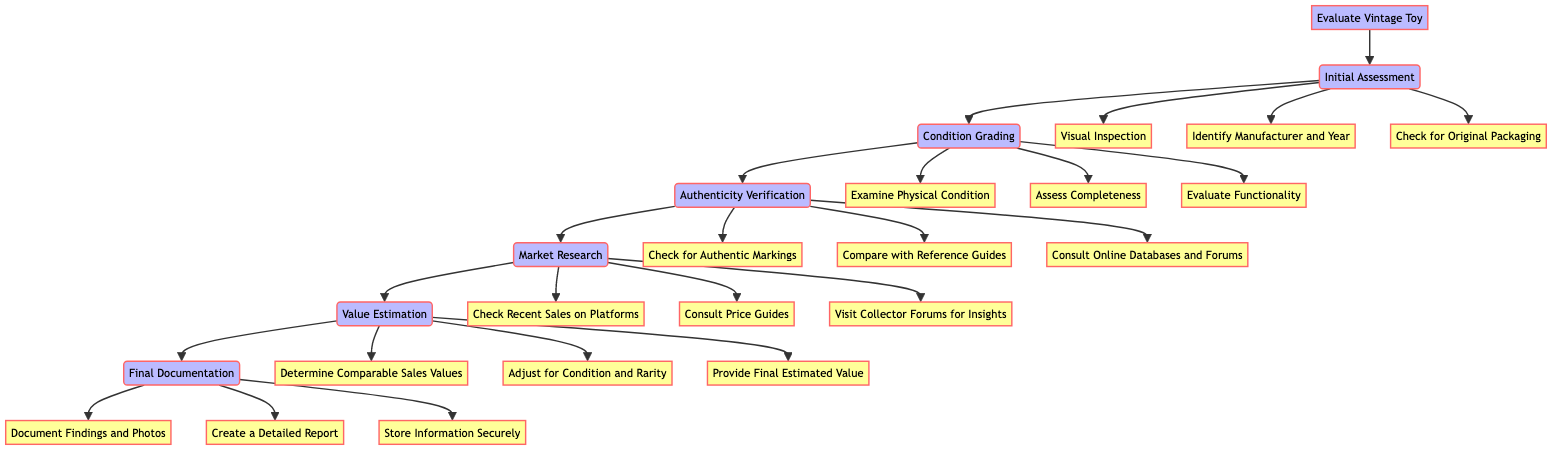What is the first step in the process? The diagram clearly indicates that the first step in the process is the "Initial Assessment." This is shown as the first node after the starting point.
Answer: Initial Assessment How many actions are listed under "Condition Grading"? In the diagram, the "Condition Grading" step has three actions connected to it: "Examine Physical Condition," "Assess Completeness," and "Evaluate Functionality." Therefore, the count of actions is three.
Answer: Three What are the actions included in the "Final Documentation" step? The "Final Documentation" step has three specific actions outlined: "Document Findings and Photos," "Create a Detailed Report," and "Store Information Securely." These actions represent the tasks to be completed during this step.
Answer: Document Findings and Photos, Create a Detailed Report, Store Information Securely Which step follows "Authenticity Verification"? Looking at the flowchart, the step that follows "Authenticity Verification" is "Market Research." This relationship is explicitly defined by the directional arrow connecting the two steps.
Answer: Market Research What is the last step in the evaluation process? According to the diagram, the last step in the evaluation process is "Final Documentation." This is the last node connected to the flowchart sequence, indicating it concludes the process.
Answer: Final Documentation Which step involves checking for recent sales on platforms like eBay? The action connected to this task is part of the "Market Research" step. The diagram shows that "Check Recent Sales on Platforms like eBay" is specifically listed under this category.
Answer: Market Research How many steps are there in total in the evaluation process? Upon reviewing the diagram, it can be observed that there are six steps outlined throughout the evaluation process, starting from "Initial Assessment" to the final "Final Documentation."
Answer: Six What are the three actions under "Authenticity Verification"? The diagram lists three actions associated with "Authenticity Verification": "Check for Authentic Markings," "Compare with Reference Guides," and "Consult Online Databases and Forums." These actions help in verifying the authenticity of the vintage toy.
Answer: Check for Authentic Markings, Compare with Reference Guides, Consult Online Databases and Forums In which step would you evaluate functionality? The evaluation of functionality is explicitly indicated as part of the "Condition Grading" step. The diagram connects this action as a necessary evaluation component for assessing the toy's overall condition.
Answer: Condition Grading 